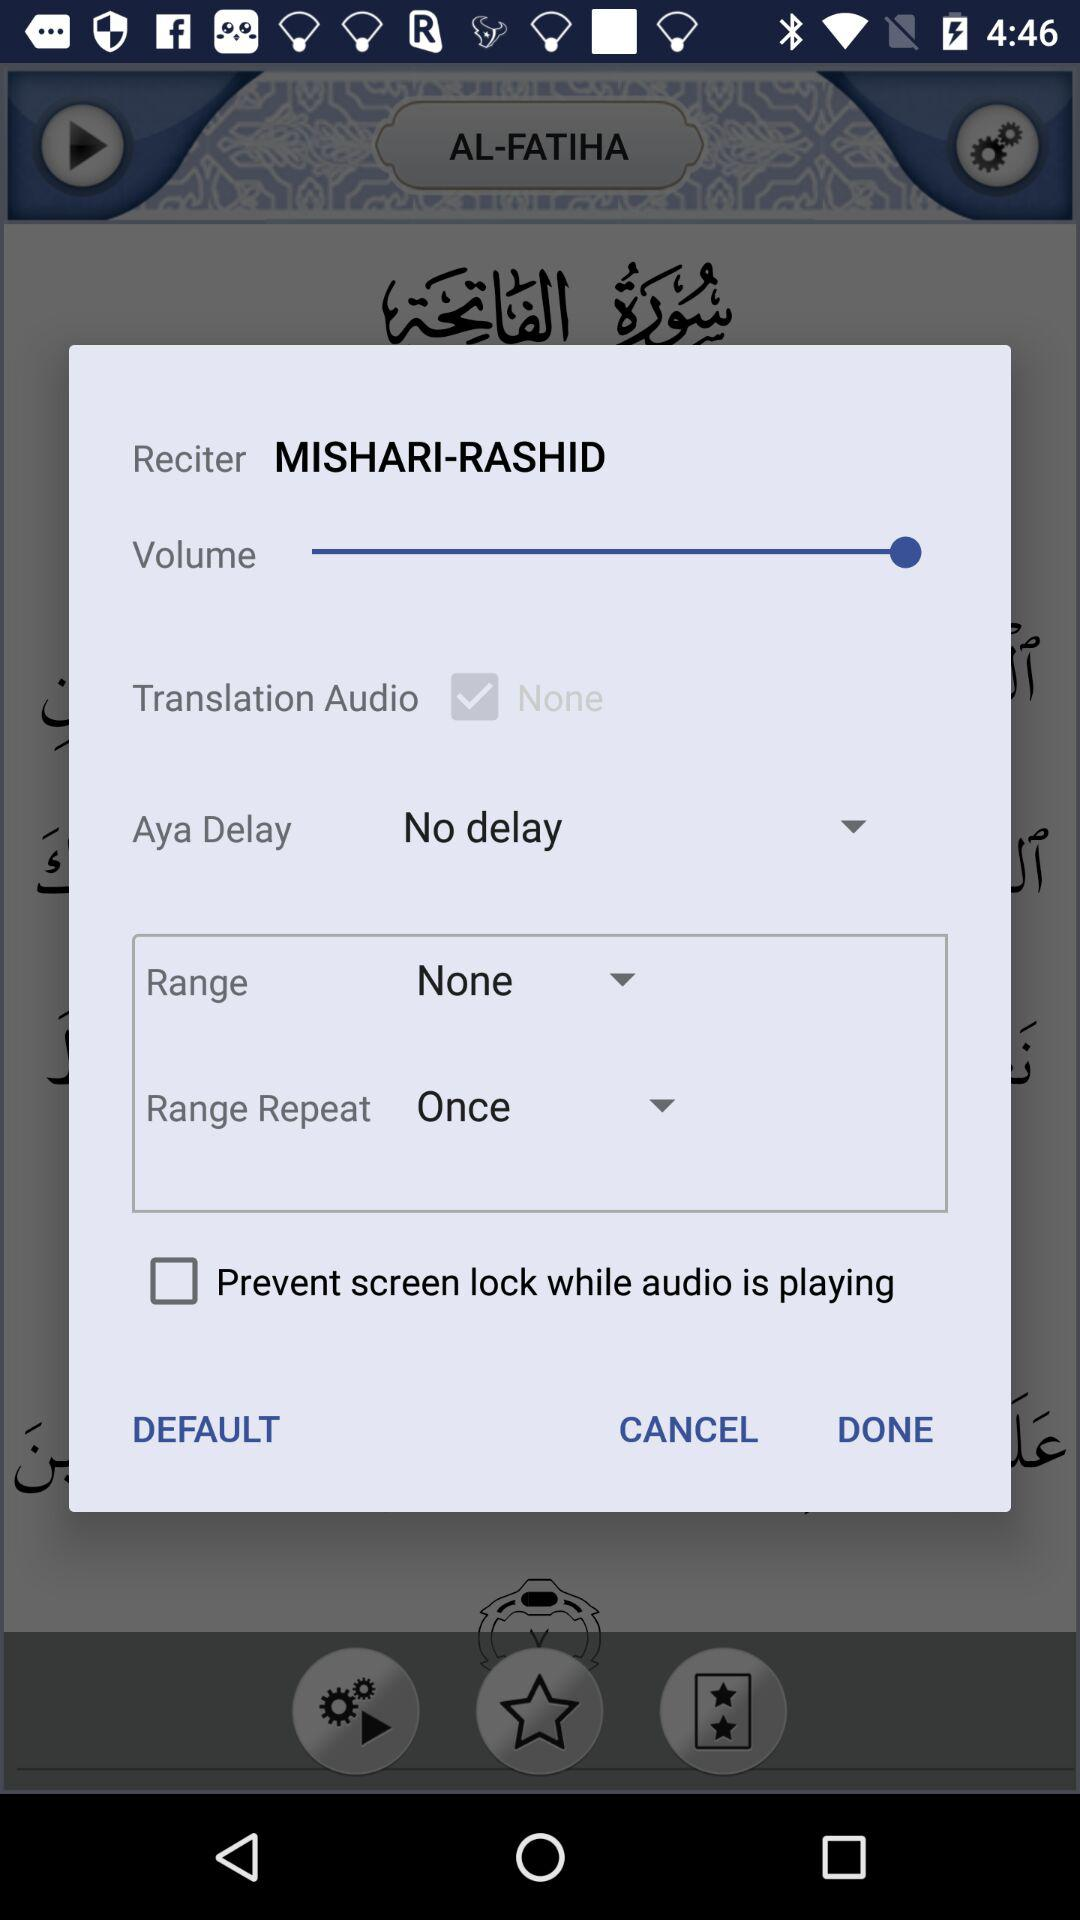What is the status of "Prevent screen lock while audio is playing"? The status is "off". 